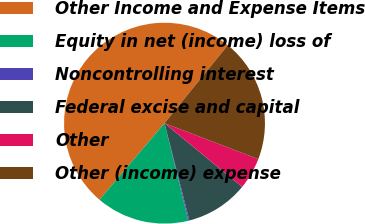Convert chart to OTSL. <chart><loc_0><loc_0><loc_500><loc_500><pie_chart><fcel>Other Income and Expense Items<fcel>Equity in net (income) loss of<fcel>Noncontrolling interest<fcel>Federal excise and capital<fcel>Other<fcel>Other (income) expense<nl><fcel>49.65%<fcel>15.02%<fcel>0.17%<fcel>10.07%<fcel>5.12%<fcel>19.97%<nl></chart> 